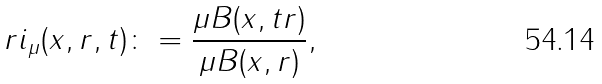Convert formula to latex. <formula><loc_0><loc_0><loc_500><loc_500>r i _ { \mu } ( x , r , t ) \colon = \frac { \mu B ( x , t r ) } { \mu B ( x , r ) } ,</formula> 